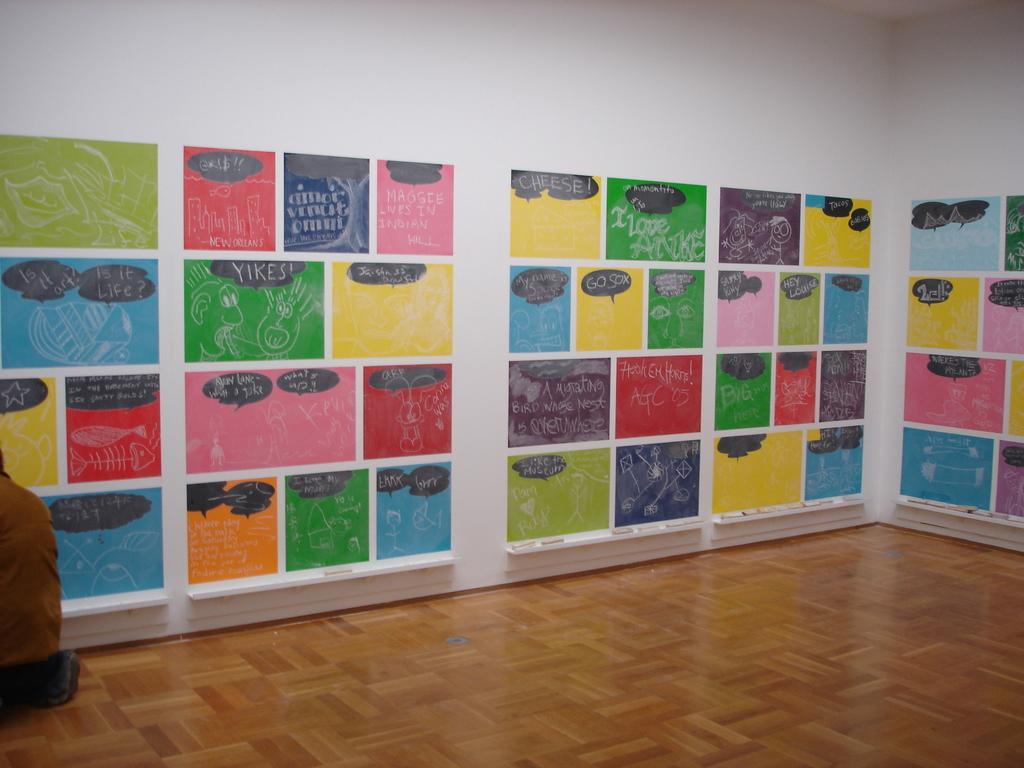Please provide a concise description of this image. On the left side of the image we can see one person wearing brown color jacket. In the background there is a wall. And we can see some painting on the wall. And there is a floor and a few other objects. 